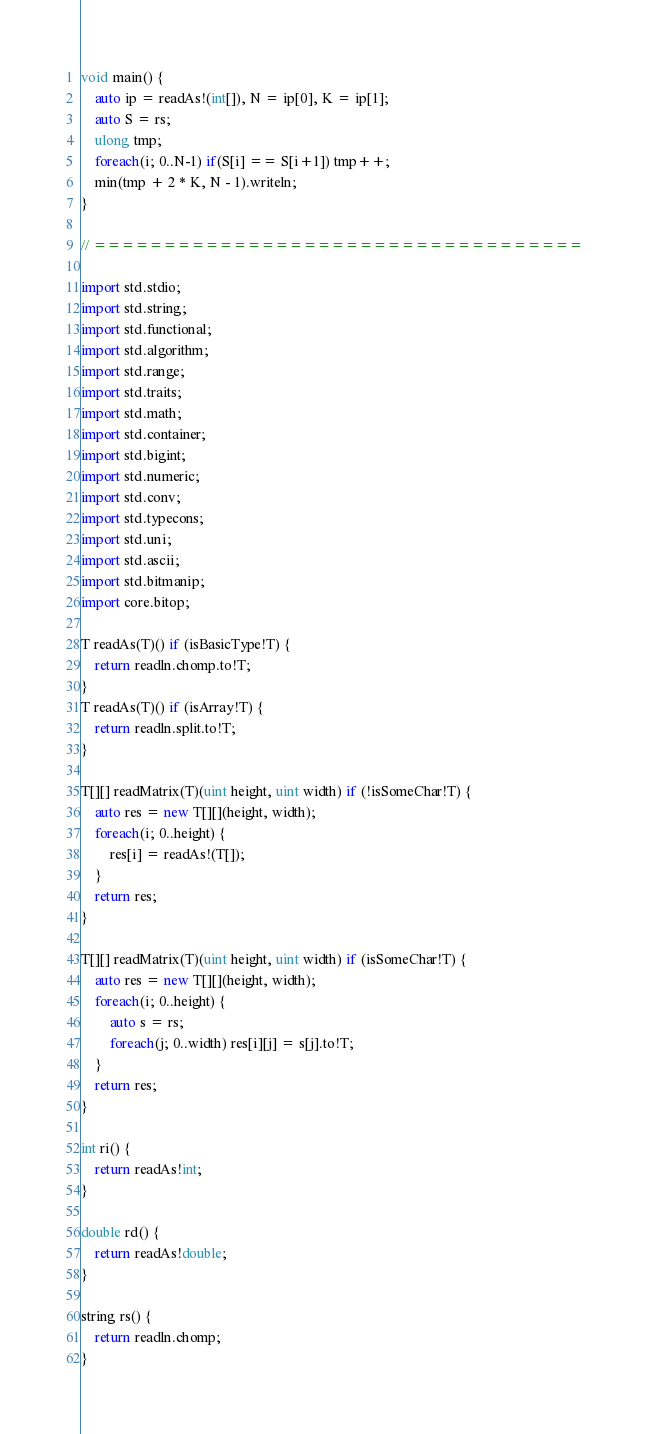Convert code to text. <code><loc_0><loc_0><loc_500><loc_500><_D_>void main() {
	auto ip = readAs!(int[]), N = ip[0], K = ip[1];
	auto S = rs;
	ulong tmp;
	foreach(i; 0..N-1) if(S[i] == S[i+1]) tmp++;
	min(tmp + 2 * K, N - 1).writeln;
}

// ===================================

import std.stdio;
import std.string;
import std.functional;
import std.algorithm;
import std.range;
import std.traits;
import std.math;
import std.container;
import std.bigint;
import std.numeric;
import std.conv;
import std.typecons;
import std.uni;
import std.ascii;
import std.bitmanip;
import core.bitop;

T readAs(T)() if (isBasicType!T) {
	return readln.chomp.to!T;
}
T readAs(T)() if (isArray!T) {
	return readln.split.to!T;
}

T[][] readMatrix(T)(uint height, uint width) if (!isSomeChar!T) {
	auto res = new T[][](height, width);
	foreach(i; 0..height) {
		res[i] = readAs!(T[]);
	}
	return res;
}

T[][] readMatrix(T)(uint height, uint width) if (isSomeChar!T) {
	auto res = new T[][](height, width);
	foreach(i; 0..height) {
		auto s = rs;
		foreach(j; 0..width) res[i][j] = s[j].to!T;
	}
	return res;
}

int ri() {
	return readAs!int;
}

double rd() {
	return readAs!double;
}

string rs() {
	return readln.chomp;
}</code> 